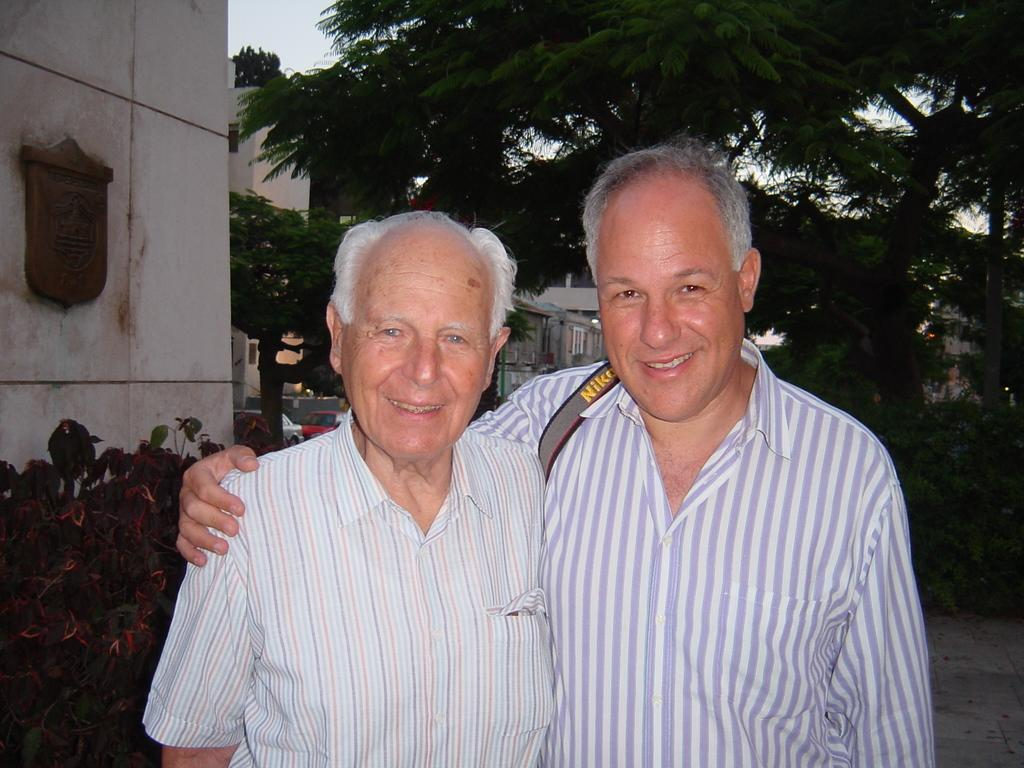Provide a one-sentence caption for the provided image. Two men posing for a picture one wearing a Nikon photo strap. 